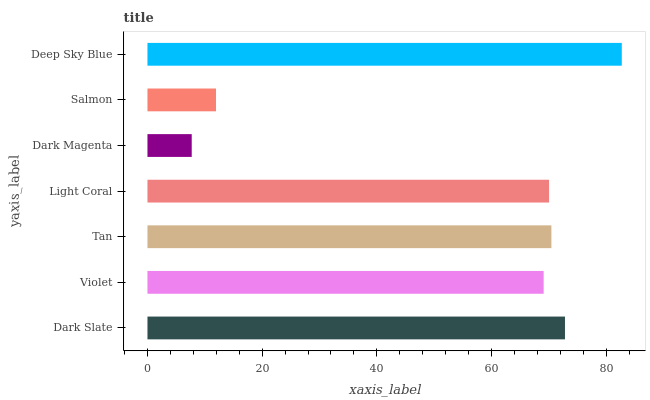Is Dark Magenta the minimum?
Answer yes or no. Yes. Is Deep Sky Blue the maximum?
Answer yes or no. Yes. Is Violet the minimum?
Answer yes or no. No. Is Violet the maximum?
Answer yes or no. No. Is Dark Slate greater than Violet?
Answer yes or no. Yes. Is Violet less than Dark Slate?
Answer yes or no. Yes. Is Violet greater than Dark Slate?
Answer yes or no. No. Is Dark Slate less than Violet?
Answer yes or no. No. Is Light Coral the high median?
Answer yes or no. Yes. Is Light Coral the low median?
Answer yes or no. Yes. Is Tan the high median?
Answer yes or no. No. Is Tan the low median?
Answer yes or no. No. 